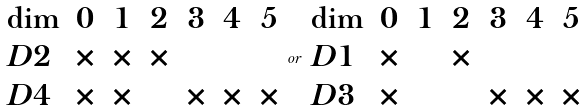<formula> <loc_0><loc_0><loc_500><loc_500>\begin{array} { l c c c c c c } \dim & 0 & 1 & 2 & 3 & 4 & 5 \\ D 2 & \times & \times & \times & & & \\ D 4 & \times & \times & & \times & \times & \times \end{array} o r \begin{array} { l c c c c c c } \dim & 0 & 1 & 2 & 3 & 4 & 5 \\ D 1 & \times & & \times & & & \\ D 3 & \times & & & \times & \times & \times \end{array}</formula> 